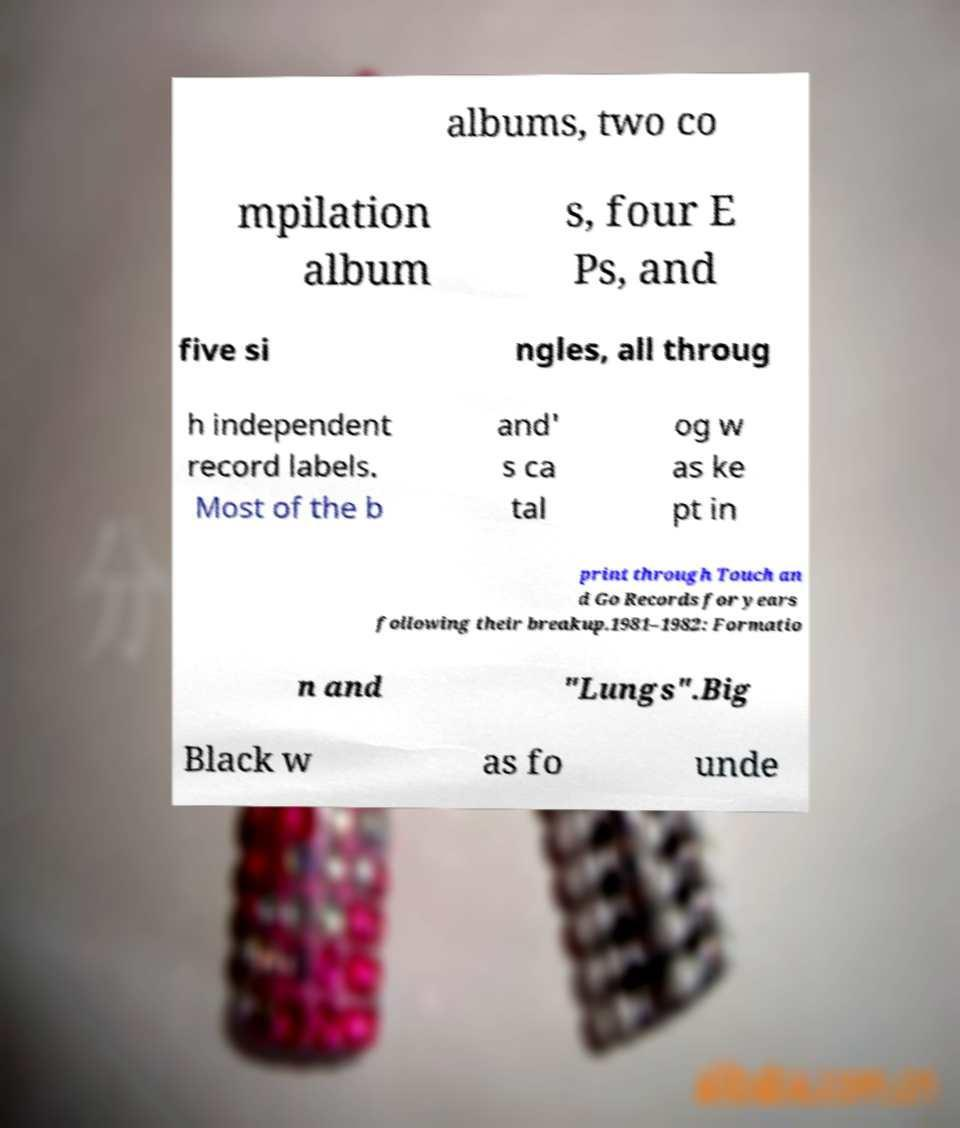Please read and relay the text visible in this image. What does it say? albums, two co mpilation album s, four E Ps, and five si ngles, all throug h independent record labels. Most of the b and' s ca tal og w as ke pt in print through Touch an d Go Records for years following their breakup.1981–1982: Formatio n and "Lungs".Big Black w as fo unde 